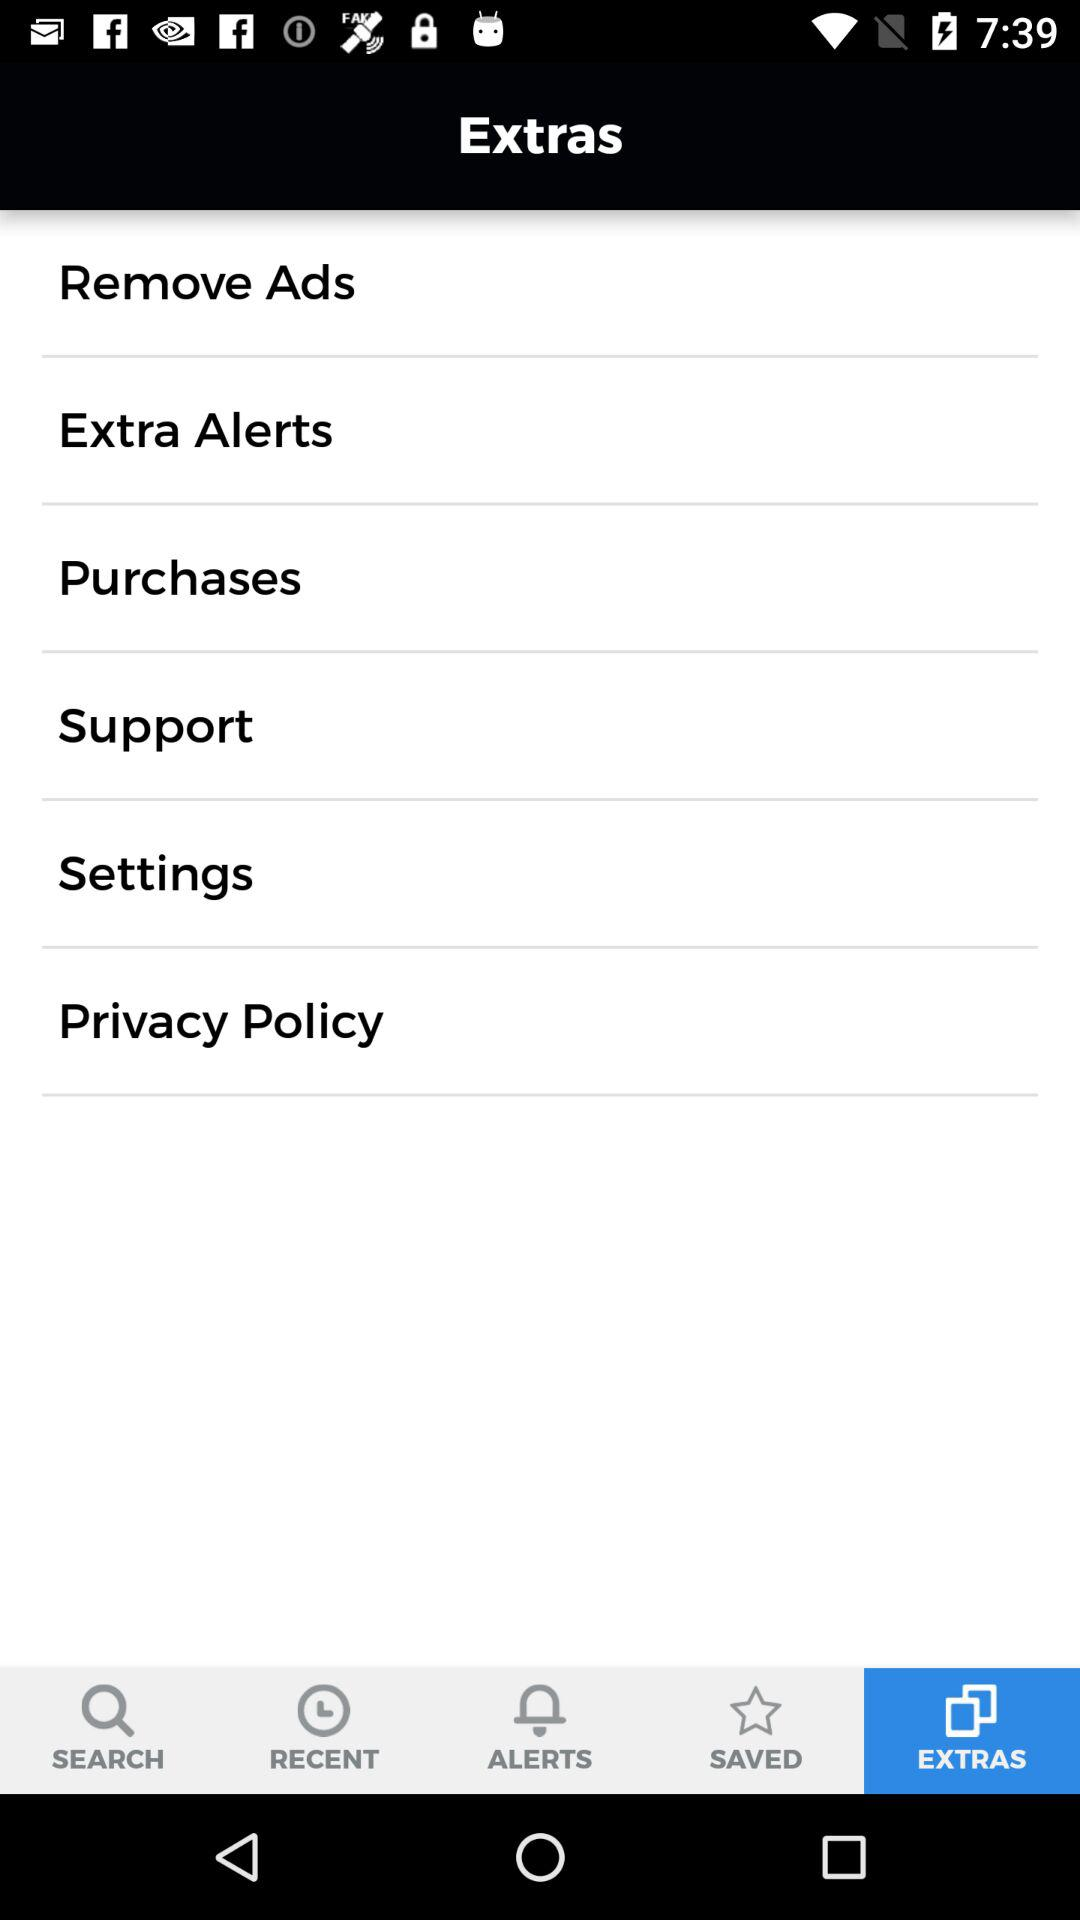Which is the selected tab? The selected tab is "EXTRAS". 